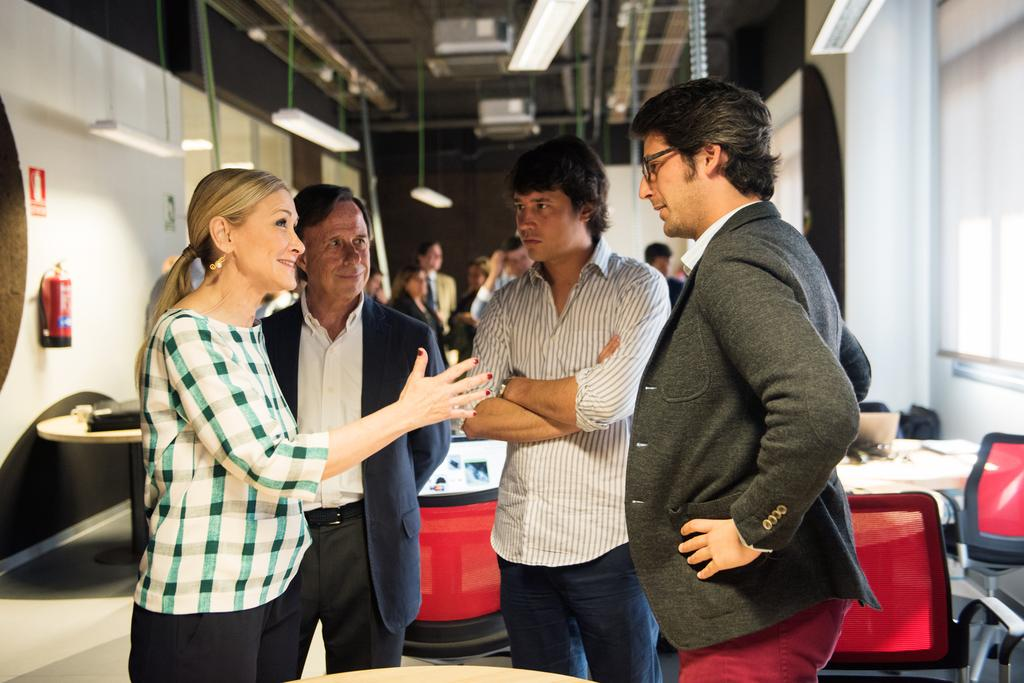How many people are in the image? There are four people in the image. What are the people in the image doing? The people are talking and looking at each other. What can be seen in the background of the image? There are tables and chairs in the background of the image. Are there any other people visible in the image? Yes, there are other people visible in the background of the image. What is the title of the book that one of the people is holding in the image? There is no book visible in the image, so it is not possible to determine the title. 